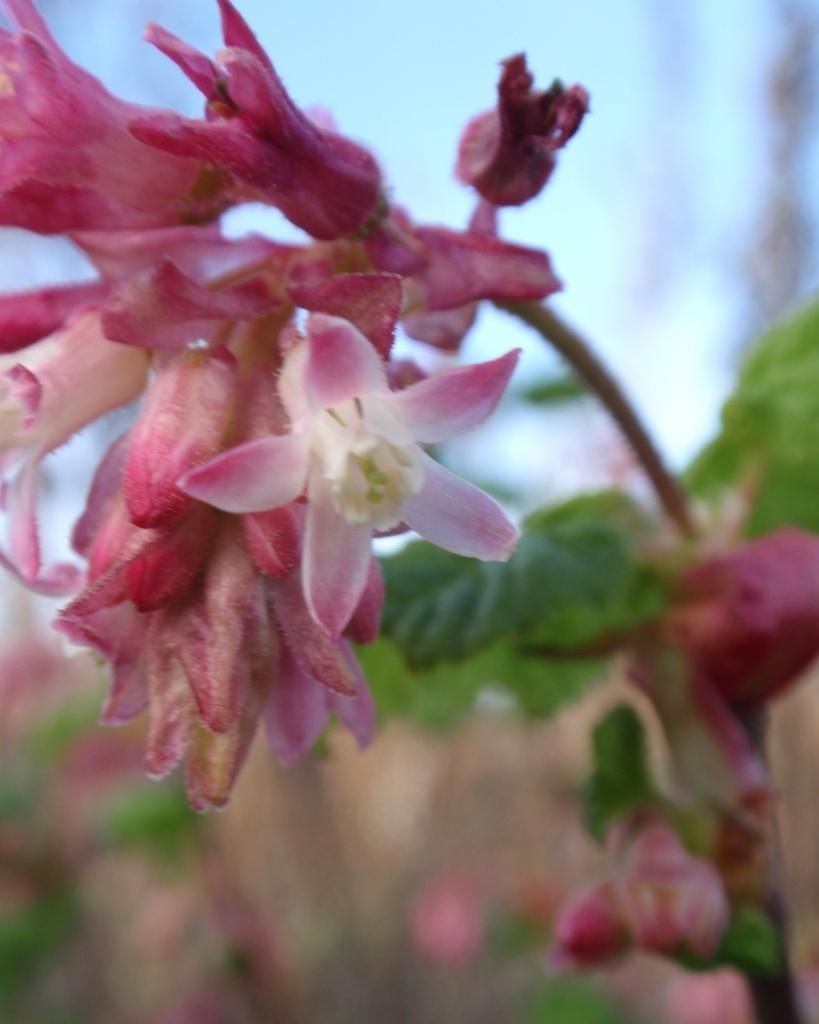What is located in the foreground of the picture? There are flowers, buds, leaves, and a stem in the foreground of the picture. What type of plant is depicted in the foreground? The plant is in the foreground of the picture. Can you describe the background of the image? The background of the image is blurred. How does the steam rise from the quarter in the image? There is no steam or quarter present in the image; it features flowers, buds, leaves, and a stem in the foreground with a blurred background. 